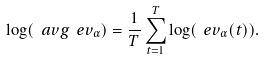<formula> <loc_0><loc_0><loc_500><loc_500>\log ( \ a v g { \ e v _ { \alpha } } ) = \frac { 1 } { T } \sum _ { t = 1 } ^ { T } \log ( \ e v _ { \alpha } ( t ) ) .</formula> 